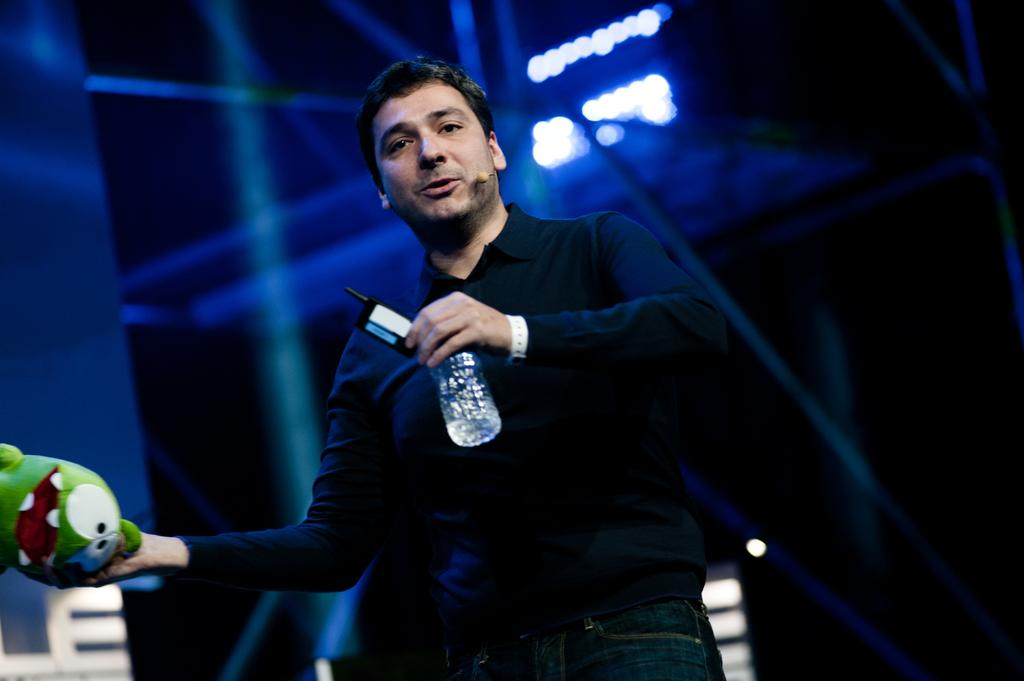What is the person in the image wearing? The person is wearing a black T-shirt. What is the person holding in the image? The person is holding a bottle and a toy. What is the person's posture in the image? The person is standing. How would you describe the background of the image? The background of the image is dark and slightly blurred. How many boots can be seen in the image? There are no boots present in the image. Are there any cows visible in the image? There are no cows present in the image. 